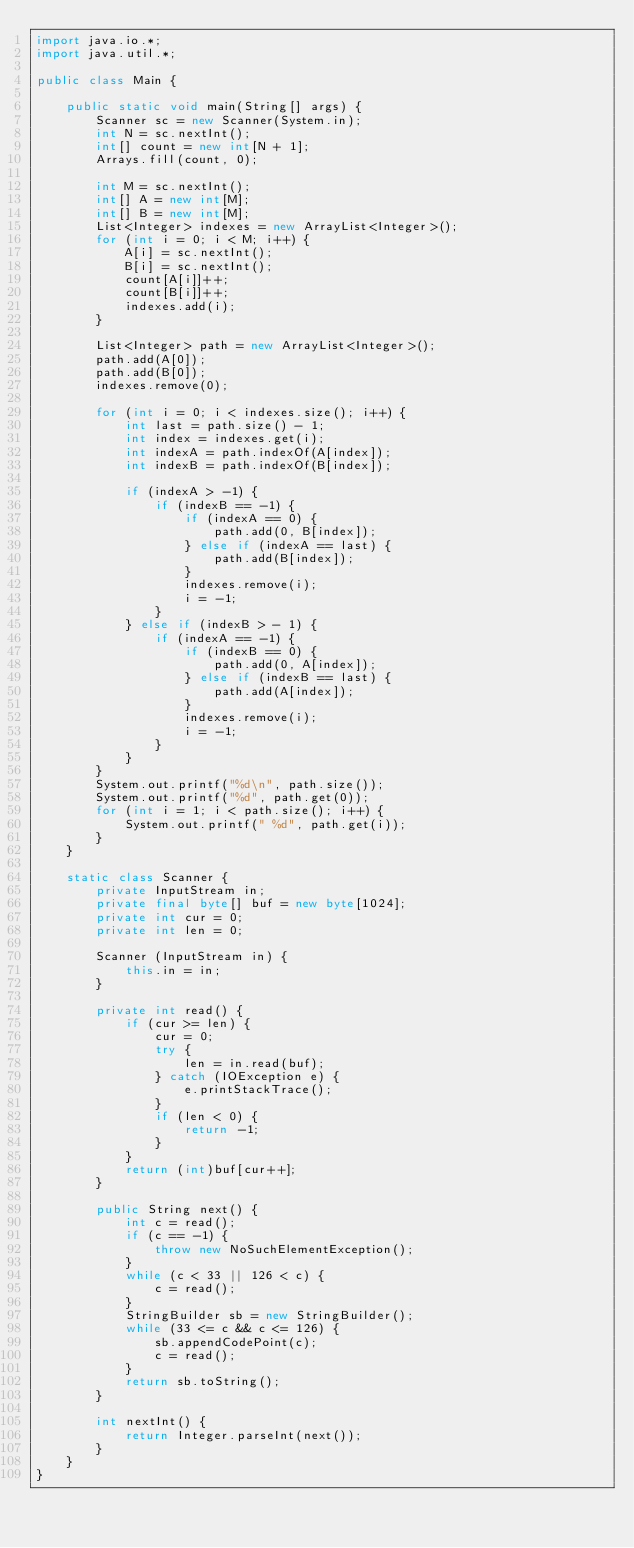Convert code to text. <code><loc_0><loc_0><loc_500><loc_500><_Java_>import java.io.*;
import java.util.*;

public class Main {

	public static void main(String[] args) {
		Scanner sc = new Scanner(System.in);
		int N = sc.nextInt();
		int[] count = new int[N + 1];
		Arrays.fill(count, 0);

		int M = sc.nextInt();
		int[] A = new int[M];
		int[] B = new int[M];
		List<Integer> indexes = new ArrayList<Integer>();
		for (int i = 0; i < M; i++) {
			A[i] = sc.nextInt();
			B[i] = sc.nextInt();
			count[A[i]]++;
			count[B[i]]++;
			indexes.add(i);
		}

		List<Integer> path = new ArrayList<Integer>();
		path.add(A[0]);
		path.add(B[0]);
		indexes.remove(0);

		for (int i = 0; i < indexes.size(); i++) {
			int last = path.size() - 1;
			int index = indexes.get(i);
			int indexA = path.indexOf(A[index]);
			int indexB = path.indexOf(B[index]);
			
			if (indexA > -1) {
				if (indexB == -1) {
					if (indexA == 0) {
						path.add(0, B[index]);
					} else if (indexA == last) {
						path.add(B[index]);
					}
					indexes.remove(i);
					i = -1;
				}
			} else if (indexB > - 1) {
				if (indexA == -1) {
					if (indexB == 0) {
						path.add(0, A[index]);
					} else if (indexB == last) {
						path.add(A[index]);
					}
					indexes.remove(i);
					i = -1;
				}
			}
		}
		System.out.printf("%d\n", path.size());
		System.out.printf("%d", path.get(0));
		for (int i = 1; i < path.size(); i++) {
			System.out.printf(" %d", path.get(i));
		}
	}

	static class Scanner {
		private InputStream in;
		private final byte[] buf = new byte[1024];
		private int cur = 0;
		private int len = 0;

		Scanner (InputStream in) {
			this.in = in;
		}

		private int read() {
			if (cur >= len) {
				cur = 0;
				try {
					len = in.read(buf);
				} catch (IOException e) {
					e.printStackTrace();
				}
				if (len < 0) {
					return -1;
				}
			}
			return (int)buf[cur++];
		}

		public String next() {
			int c = read();
			if (c == -1) {
				throw new NoSuchElementException();
			}
			while (c < 33 || 126 < c) {
				c = read();
			}
			StringBuilder sb = new StringBuilder();
			while (33 <= c && c <= 126) {
				sb.appendCodePoint(c);
				c = read();
			}
			return sb.toString();
		}

		int nextInt() {
			return Integer.parseInt(next());
		}
	}
}
</code> 